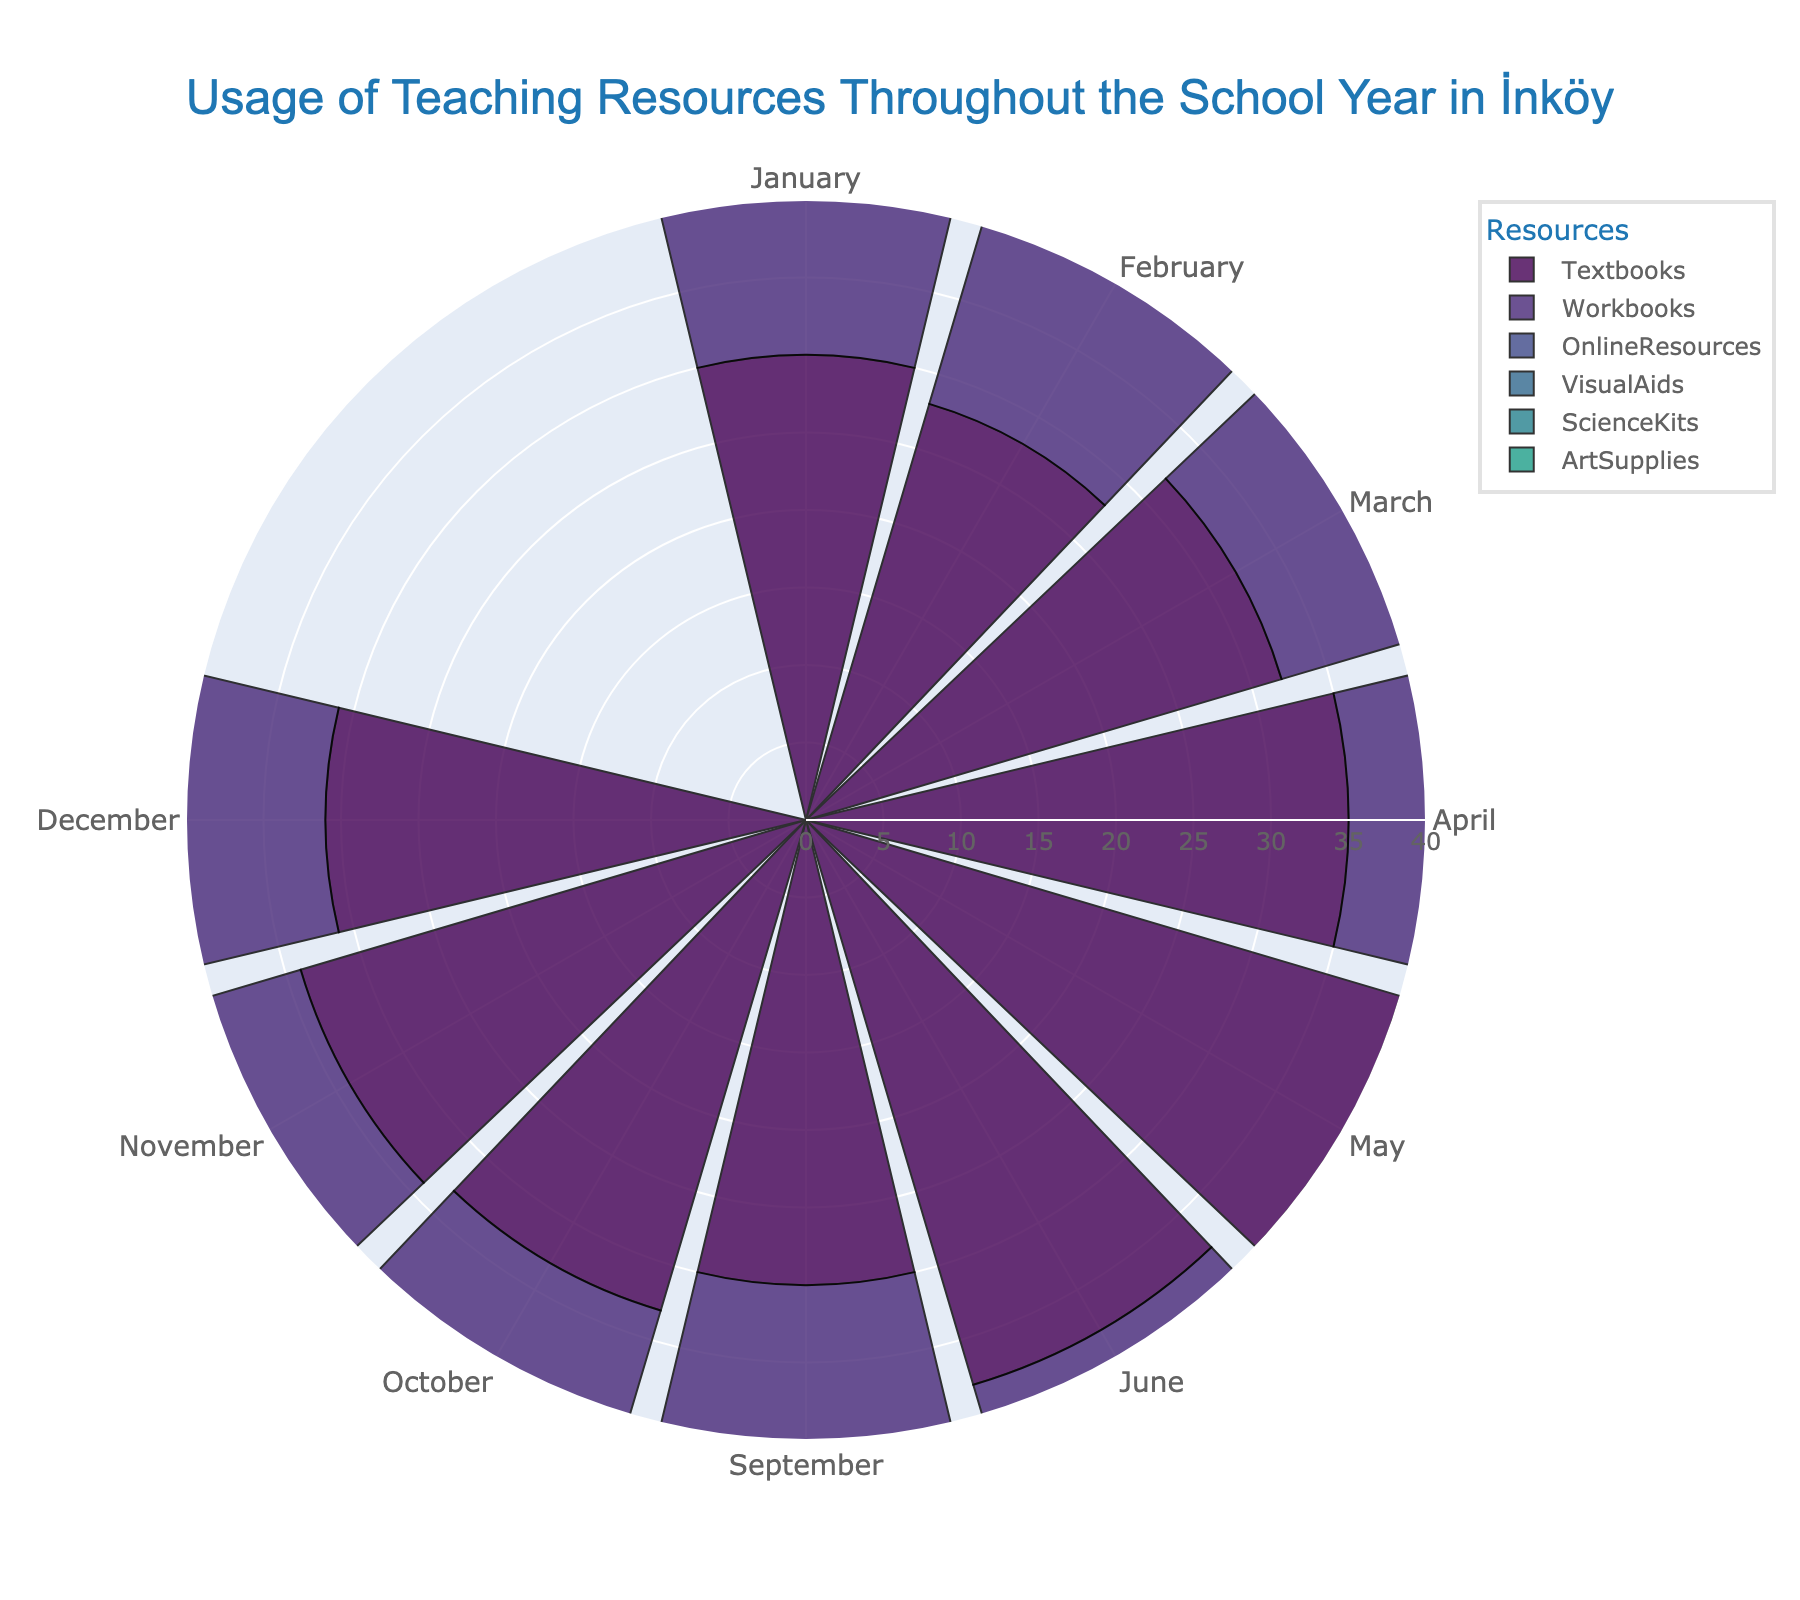what is the highest usage value for textbooks throughout the year? Look at the plot and find the month with the largest bar for textbooks. The highest value is 40 in May.
Answer: 40 in May How many resources are shown in the figure? Count the different named resources in the legend. The resources listed are Textbooks, Workbooks, OnlineResources, VisualAids, ScienceKits, and ArtSupplies.
Answer: 6 Which month shows the lowest usage of online resources? Identify the bar for online resources with the smallest radial length. The lowest value is 5 in January.
Answer: January Compare the usage of Art Supplies in February and October. Which month shows higher usage? Compare the radial lengths of Art Supplies between the two months. February shows a value of 14, whereas October shows a value of 12, so February has higher usage.
Answer: February What's the average usage of Visual Aids in the first half of the year (January to June)? Sum the values for Visual Aids from January to June and divide by 6. (10 + 12 + 14 + 16 + 18 + 17) = 87, so the average is 87 / 6 = 14.5
Answer: 14.5 Is the usage of Science Kits in June higher or lower than in September? Compare the radial lengths of Science Kits in June and September. June has 13, and September has 9; June is higher.
Answer: Higher in June Which resource shows the most consistent usage throughout the year? Look for the resource with the least variation in bar lengths. Textbooks seem to be consistently high without large drops.
Answer: Textbooks During which month is the usage of workbooks highest? Identify the month with the tallest bar for workbooks. The highest value is 22 in May.
Answer: May 